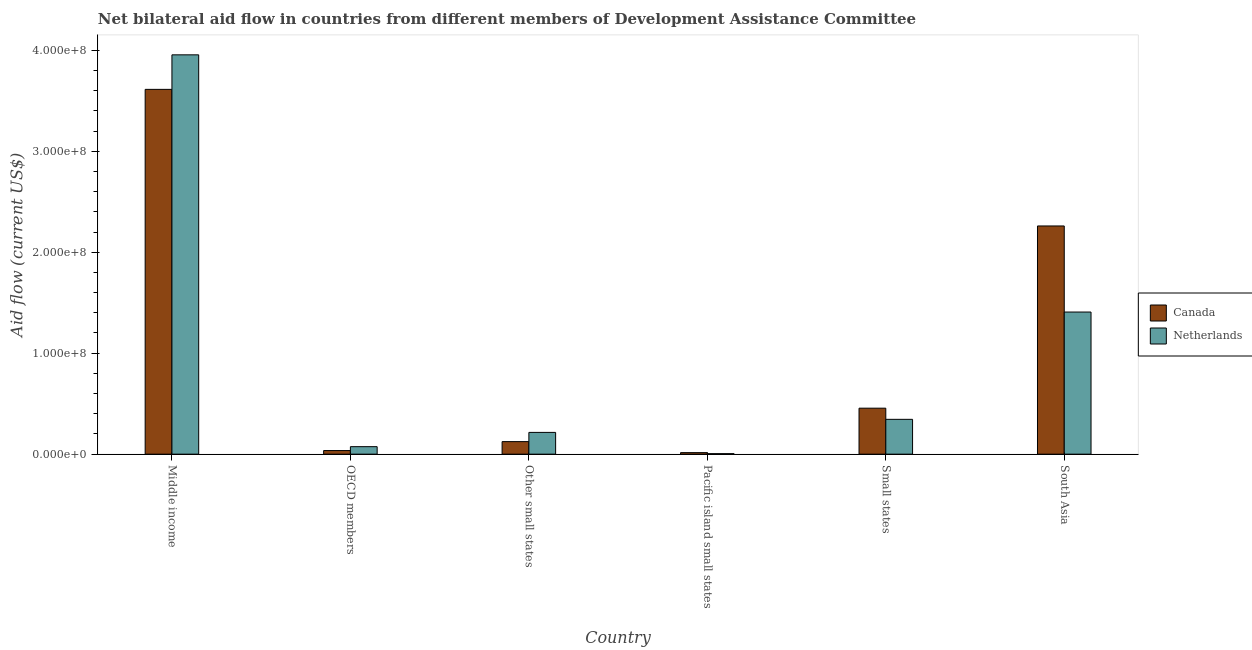How many different coloured bars are there?
Ensure brevity in your answer.  2. Are the number of bars per tick equal to the number of legend labels?
Your response must be concise. Yes. How many bars are there on the 3rd tick from the right?
Make the answer very short. 2. What is the amount of aid given by canada in South Asia?
Give a very brief answer. 2.26e+08. Across all countries, what is the maximum amount of aid given by canada?
Give a very brief answer. 3.61e+08. Across all countries, what is the minimum amount of aid given by canada?
Keep it short and to the point. 1.51e+06. In which country was the amount of aid given by netherlands maximum?
Keep it short and to the point. Middle income. In which country was the amount of aid given by canada minimum?
Make the answer very short. Pacific island small states. What is the total amount of aid given by canada in the graph?
Your response must be concise. 6.50e+08. What is the difference between the amount of aid given by canada in Middle income and that in Other small states?
Your response must be concise. 3.49e+08. What is the difference between the amount of aid given by netherlands in Pacific island small states and the amount of aid given by canada in South Asia?
Give a very brief answer. -2.26e+08. What is the average amount of aid given by canada per country?
Offer a terse response. 1.08e+08. What is the difference between the amount of aid given by netherlands and amount of aid given by canada in Other small states?
Your answer should be compact. 9.12e+06. In how many countries, is the amount of aid given by netherlands greater than 60000000 US$?
Your answer should be very brief. 2. What is the ratio of the amount of aid given by canada in OECD members to that in Small states?
Your answer should be compact. 0.08. Is the difference between the amount of aid given by canada in Middle income and Pacific island small states greater than the difference between the amount of aid given by netherlands in Middle income and Pacific island small states?
Provide a short and direct response. No. What is the difference between the highest and the second highest amount of aid given by canada?
Offer a terse response. 1.35e+08. What is the difference between the highest and the lowest amount of aid given by canada?
Provide a succinct answer. 3.60e+08. In how many countries, is the amount of aid given by netherlands greater than the average amount of aid given by netherlands taken over all countries?
Give a very brief answer. 2. How many bars are there?
Provide a short and direct response. 12. Are all the bars in the graph horizontal?
Offer a terse response. No. How many countries are there in the graph?
Provide a short and direct response. 6. What is the difference between two consecutive major ticks on the Y-axis?
Keep it short and to the point. 1.00e+08. Does the graph contain any zero values?
Offer a very short reply. No. Does the graph contain grids?
Make the answer very short. No. What is the title of the graph?
Provide a succinct answer. Net bilateral aid flow in countries from different members of Development Assistance Committee. What is the Aid flow (current US$) in Canada in Middle income?
Your answer should be very brief. 3.61e+08. What is the Aid flow (current US$) of Netherlands in Middle income?
Your answer should be compact. 3.95e+08. What is the Aid flow (current US$) in Canada in OECD members?
Your answer should be compact. 3.58e+06. What is the Aid flow (current US$) in Netherlands in OECD members?
Your answer should be very brief. 7.42e+06. What is the Aid flow (current US$) of Canada in Other small states?
Make the answer very short. 1.24e+07. What is the Aid flow (current US$) of Netherlands in Other small states?
Ensure brevity in your answer.  2.16e+07. What is the Aid flow (current US$) in Canada in Pacific island small states?
Provide a succinct answer. 1.51e+06. What is the Aid flow (current US$) of Canada in Small states?
Make the answer very short. 4.55e+07. What is the Aid flow (current US$) in Netherlands in Small states?
Provide a short and direct response. 3.45e+07. What is the Aid flow (current US$) in Canada in South Asia?
Your answer should be compact. 2.26e+08. What is the Aid flow (current US$) in Netherlands in South Asia?
Offer a very short reply. 1.41e+08. Across all countries, what is the maximum Aid flow (current US$) of Canada?
Your response must be concise. 3.61e+08. Across all countries, what is the maximum Aid flow (current US$) in Netherlands?
Ensure brevity in your answer.  3.95e+08. Across all countries, what is the minimum Aid flow (current US$) in Canada?
Keep it short and to the point. 1.51e+06. Across all countries, what is the minimum Aid flow (current US$) of Netherlands?
Ensure brevity in your answer.  4.90e+05. What is the total Aid flow (current US$) in Canada in the graph?
Your response must be concise. 6.50e+08. What is the total Aid flow (current US$) in Netherlands in the graph?
Your answer should be very brief. 6.00e+08. What is the difference between the Aid flow (current US$) in Canada in Middle income and that in OECD members?
Provide a succinct answer. 3.58e+08. What is the difference between the Aid flow (current US$) of Netherlands in Middle income and that in OECD members?
Provide a succinct answer. 3.88e+08. What is the difference between the Aid flow (current US$) in Canada in Middle income and that in Other small states?
Your answer should be very brief. 3.49e+08. What is the difference between the Aid flow (current US$) in Netherlands in Middle income and that in Other small states?
Keep it short and to the point. 3.74e+08. What is the difference between the Aid flow (current US$) in Canada in Middle income and that in Pacific island small states?
Your response must be concise. 3.60e+08. What is the difference between the Aid flow (current US$) of Netherlands in Middle income and that in Pacific island small states?
Give a very brief answer. 3.95e+08. What is the difference between the Aid flow (current US$) of Canada in Middle income and that in Small states?
Provide a succinct answer. 3.16e+08. What is the difference between the Aid flow (current US$) of Netherlands in Middle income and that in Small states?
Keep it short and to the point. 3.61e+08. What is the difference between the Aid flow (current US$) of Canada in Middle income and that in South Asia?
Make the answer very short. 1.35e+08. What is the difference between the Aid flow (current US$) of Netherlands in Middle income and that in South Asia?
Make the answer very short. 2.55e+08. What is the difference between the Aid flow (current US$) in Canada in OECD members and that in Other small states?
Your answer should be compact. -8.85e+06. What is the difference between the Aid flow (current US$) of Netherlands in OECD members and that in Other small states?
Your answer should be very brief. -1.41e+07. What is the difference between the Aid flow (current US$) of Canada in OECD members and that in Pacific island small states?
Give a very brief answer. 2.07e+06. What is the difference between the Aid flow (current US$) in Netherlands in OECD members and that in Pacific island small states?
Ensure brevity in your answer.  6.93e+06. What is the difference between the Aid flow (current US$) of Canada in OECD members and that in Small states?
Provide a succinct answer. -4.20e+07. What is the difference between the Aid flow (current US$) of Netherlands in OECD members and that in Small states?
Ensure brevity in your answer.  -2.71e+07. What is the difference between the Aid flow (current US$) in Canada in OECD members and that in South Asia?
Make the answer very short. -2.22e+08. What is the difference between the Aid flow (current US$) of Netherlands in OECD members and that in South Asia?
Your answer should be very brief. -1.33e+08. What is the difference between the Aid flow (current US$) in Canada in Other small states and that in Pacific island small states?
Offer a very short reply. 1.09e+07. What is the difference between the Aid flow (current US$) in Netherlands in Other small states and that in Pacific island small states?
Your response must be concise. 2.11e+07. What is the difference between the Aid flow (current US$) of Canada in Other small states and that in Small states?
Give a very brief answer. -3.31e+07. What is the difference between the Aid flow (current US$) of Netherlands in Other small states and that in Small states?
Your answer should be compact. -1.30e+07. What is the difference between the Aid flow (current US$) in Canada in Other small states and that in South Asia?
Make the answer very short. -2.14e+08. What is the difference between the Aid flow (current US$) in Netherlands in Other small states and that in South Asia?
Offer a very short reply. -1.19e+08. What is the difference between the Aid flow (current US$) in Canada in Pacific island small states and that in Small states?
Your answer should be compact. -4.40e+07. What is the difference between the Aid flow (current US$) in Netherlands in Pacific island small states and that in Small states?
Offer a very short reply. -3.40e+07. What is the difference between the Aid flow (current US$) of Canada in Pacific island small states and that in South Asia?
Your response must be concise. -2.24e+08. What is the difference between the Aid flow (current US$) in Netherlands in Pacific island small states and that in South Asia?
Your answer should be compact. -1.40e+08. What is the difference between the Aid flow (current US$) in Canada in Small states and that in South Asia?
Your response must be concise. -1.80e+08. What is the difference between the Aid flow (current US$) in Netherlands in Small states and that in South Asia?
Give a very brief answer. -1.06e+08. What is the difference between the Aid flow (current US$) of Canada in Middle income and the Aid flow (current US$) of Netherlands in OECD members?
Your answer should be very brief. 3.54e+08. What is the difference between the Aid flow (current US$) in Canada in Middle income and the Aid flow (current US$) in Netherlands in Other small states?
Provide a succinct answer. 3.40e+08. What is the difference between the Aid flow (current US$) of Canada in Middle income and the Aid flow (current US$) of Netherlands in Pacific island small states?
Your answer should be very brief. 3.61e+08. What is the difference between the Aid flow (current US$) of Canada in Middle income and the Aid flow (current US$) of Netherlands in Small states?
Your response must be concise. 3.27e+08. What is the difference between the Aid flow (current US$) in Canada in Middle income and the Aid flow (current US$) in Netherlands in South Asia?
Ensure brevity in your answer.  2.21e+08. What is the difference between the Aid flow (current US$) in Canada in OECD members and the Aid flow (current US$) in Netherlands in Other small states?
Your answer should be very brief. -1.80e+07. What is the difference between the Aid flow (current US$) in Canada in OECD members and the Aid flow (current US$) in Netherlands in Pacific island small states?
Provide a short and direct response. 3.09e+06. What is the difference between the Aid flow (current US$) in Canada in OECD members and the Aid flow (current US$) in Netherlands in Small states?
Ensure brevity in your answer.  -3.09e+07. What is the difference between the Aid flow (current US$) of Canada in OECD members and the Aid flow (current US$) of Netherlands in South Asia?
Your answer should be very brief. -1.37e+08. What is the difference between the Aid flow (current US$) in Canada in Other small states and the Aid flow (current US$) in Netherlands in Pacific island small states?
Give a very brief answer. 1.19e+07. What is the difference between the Aid flow (current US$) of Canada in Other small states and the Aid flow (current US$) of Netherlands in Small states?
Make the answer very short. -2.21e+07. What is the difference between the Aid flow (current US$) in Canada in Other small states and the Aid flow (current US$) in Netherlands in South Asia?
Ensure brevity in your answer.  -1.28e+08. What is the difference between the Aid flow (current US$) of Canada in Pacific island small states and the Aid flow (current US$) of Netherlands in Small states?
Provide a short and direct response. -3.30e+07. What is the difference between the Aid flow (current US$) in Canada in Pacific island small states and the Aid flow (current US$) in Netherlands in South Asia?
Provide a succinct answer. -1.39e+08. What is the difference between the Aid flow (current US$) in Canada in Small states and the Aid flow (current US$) in Netherlands in South Asia?
Ensure brevity in your answer.  -9.52e+07. What is the average Aid flow (current US$) in Canada per country?
Give a very brief answer. 1.08e+08. What is the average Aid flow (current US$) in Netherlands per country?
Your answer should be very brief. 1.00e+08. What is the difference between the Aid flow (current US$) in Canada and Aid flow (current US$) in Netherlands in Middle income?
Provide a succinct answer. -3.42e+07. What is the difference between the Aid flow (current US$) in Canada and Aid flow (current US$) in Netherlands in OECD members?
Make the answer very short. -3.84e+06. What is the difference between the Aid flow (current US$) in Canada and Aid flow (current US$) in Netherlands in Other small states?
Offer a very short reply. -9.12e+06. What is the difference between the Aid flow (current US$) of Canada and Aid flow (current US$) of Netherlands in Pacific island small states?
Make the answer very short. 1.02e+06. What is the difference between the Aid flow (current US$) of Canada and Aid flow (current US$) of Netherlands in Small states?
Provide a succinct answer. 1.10e+07. What is the difference between the Aid flow (current US$) in Canada and Aid flow (current US$) in Netherlands in South Asia?
Offer a terse response. 8.53e+07. What is the ratio of the Aid flow (current US$) of Canada in Middle income to that in OECD members?
Your answer should be compact. 100.92. What is the ratio of the Aid flow (current US$) in Netherlands in Middle income to that in OECD members?
Make the answer very short. 53.3. What is the ratio of the Aid flow (current US$) of Canada in Middle income to that in Other small states?
Provide a short and direct response. 29.07. What is the ratio of the Aid flow (current US$) of Netherlands in Middle income to that in Other small states?
Provide a short and direct response. 18.35. What is the ratio of the Aid flow (current US$) in Canada in Middle income to that in Pacific island small states?
Provide a succinct answer. 239.26. What is the ratio of the Aid flow (current US$) in Netherlands in Middle income to that in Pacific island small states?
Provide a succinct answer. 807.1. What is the ratio of the Aid flow (current US$) in Canada in Middle income to that in Small states?
Your response must be concise. 7.93. What is the ratio of the Aid flow (current US$) in Netherlands in Middle income to that in Small states?
Your response must be concise. 11.46. What is the ratio of the Aid flow (current US$) in Canada in Middle income to that in South Asia?
Offer a very short reply. 1.6. What is the ratio of the Aid flow (current US$) of Netherlands in Middle income to that in South Asia?
Give a very brief answer. 2.81. What is the ratio of the Aid flow (current US$) in Canada in OECD members to that in Other small states?
Provide a succinct answer. 0.29. What is the ratio of the Aid flow (current US$) in Netherlands in OECD members to that in Other small states?
Make the answer very short. 0.34. What is the ratio of the Aid flow (current US$) in Canada in OECD members to that in Pacific island small states?
Your answer should be very brief. 2.37. What is the ratio of the Aid flow (current US$) in Netherlands in OECD members to that in Pacific island small states?
Offer a very short reply. 15.14. What is the ratio of the Aid flow (current US$) of Canada in OECD members to that in Small states?
Your answer should be very brief. 0.08. What is the ratio of the Aid flow (current US$) of Netherlands in OECD members to that in Small states?
Your response must be concise. 0.22. What is the ratio of the Aid flow (current US$) in Canada in OECD members to that in South Asia?
Make the answer very short. 0.02. What is the ratio of the Aid flow (current US$) of Netherlands in OECD members to that in South Asia?
Provide a short and direct response. 0.05. What is the ratio of the Aid flow (current US$) in Canada in Other small states to that in Pacific island small states?
Ensure brevity in your answer.  8.23. What is the ratio of the Aid flow (current US$) of Netherlands in Other small states to that in Pacific island small states?
Your answer should be very brief. 43.98. What is the ratio of the Aid flow (current US$) of Canada in Other small states to that in Small states?
Keep it short and to the point. 0.27. What is the ratio of the Aid flow (current US$) of Netherlands in Other small states to that in Small states?
Your answer should be very brief. 0.62. What is the ratio of the Aid flow (current US$) in Canada in Other small states to that in South Asia?
Offer a terse response. 0.06. What is the ratio of the Aid flow (current US$) in Netherlands in Other small states to that in South Asia?
Your response must be concise. 0.15. What is the ratio of the Aid flow (current US$) in Canada in Pacific island small states to that in Small states?
Provide a short and direct response. 0.03. What is the ratio of the Aid flow (current US$) of Netherlands in Pacific island small states to that in Small states?
Ensure brevity in your answer.  0.01. What is the ratio of the Aid flow (current US$) of Canada in Pacific island small states to that in South Asia?
Provide a succinct answer. 0.01. What is the ratio of the Aid flow (current US$) of Netherlands in Pacific island small states to that in South Asia?
Keep it short and to the point. 0. What is the ratio of the Aid flow (current US$) of Canada in Small states to that in South Asia?
Keep it short and to the point. 0.2. What is the ratio of the Aid flow (current US$) of Netherlands in Small states to that in South Asia?
Provide a short and direct response. 0.25. What is the difference between the highest and the second highest Aid flow (current US$) of Canada?
Offer a terse response. 1.35e+08. What is the difference between the highest and the second highest Aid flow (current US$) of Netherlands?
Give a very brief answer. 2.55e+08. What is the difference between the highest and the lowest Aid flow (current US$) in Canada?
Provide a short and direct response. 3.60e+08. What is the difference between the highest and the lowest Aid flow (current US$) of Netherlands?
Provide a succinct answer. 3.95e+08. 